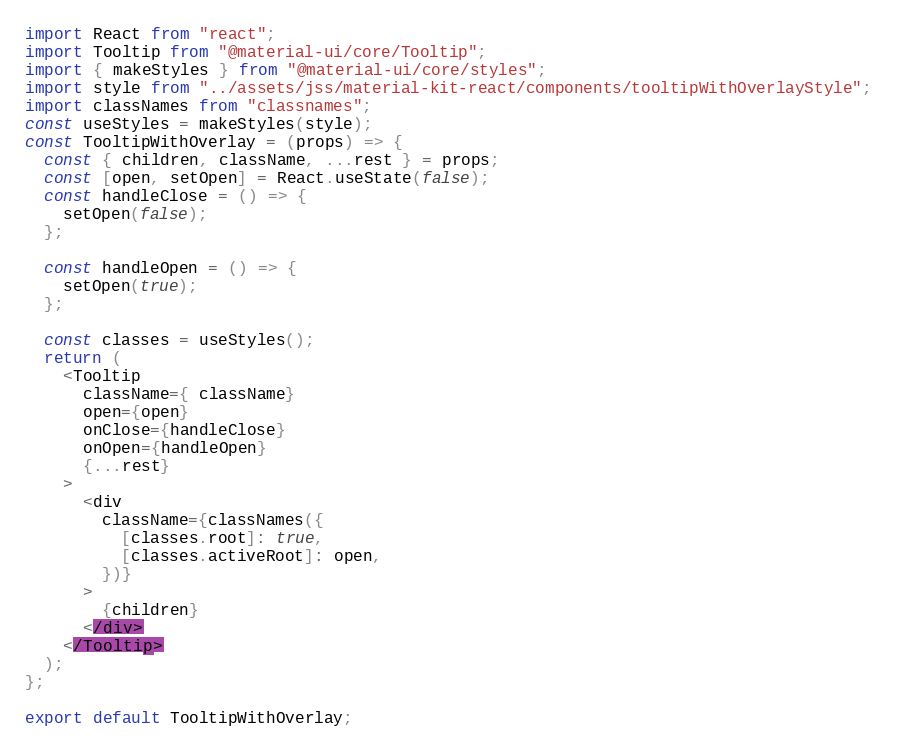Convert code to text. <code><loc_0><loc_0><loc_500><loc_500><_JavaScript_>import React from "react";
import Tooltip from "@material-ui/core/Tooltip";
import { makeStyles } from "@material-ui/core/styles";
import style from "../assets/jss/material-kit-react/components/tooltipWithOverlayStyle";
import classNames from "classnames";
const useStyles = makeStyles(style);
const TooltipWithOverlay = (props) => {
  const { children, className, ...rest } = props;
  const [open, setOpen] = React.useState(false);
  const handleClose = () => {
    setOpen(false);
  };

  const handleOpen = () => {
    setOpen(true);
  };

  const classes = useStyles();
  return (
    <Tooltip
      className={ className}
      open={open}
      onClose={handleClose}
      onOpen={handleOpen}
      {...rest}
    >
      <div
        className={classNames({
          [classes.root]: true,
          [classes.activeRoot]: open,
        })}
      >
        {children}
      </div>
    </Tooltip>
  );
};

export default TooltipWithOverlay;
</code> 